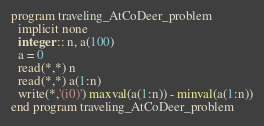<code> <loc_0><loc_0><loc_500><loc_500><_FORTRAN_>program traveling_AtCoDeer_problem
  implicit none
  integer :: n, a(100)
  a = 0
  read(*,*) n
  read(*,*) a(1:n)
  write(*,'(i0)') maxval(a(1:n)) - minval(a(1:n))
end program traveling_AtCoDeer_problem
</code> 